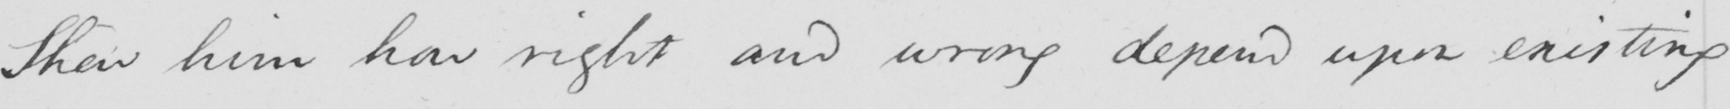What text is written in this handwritten line? Show him how right and wrong depend upon existing 